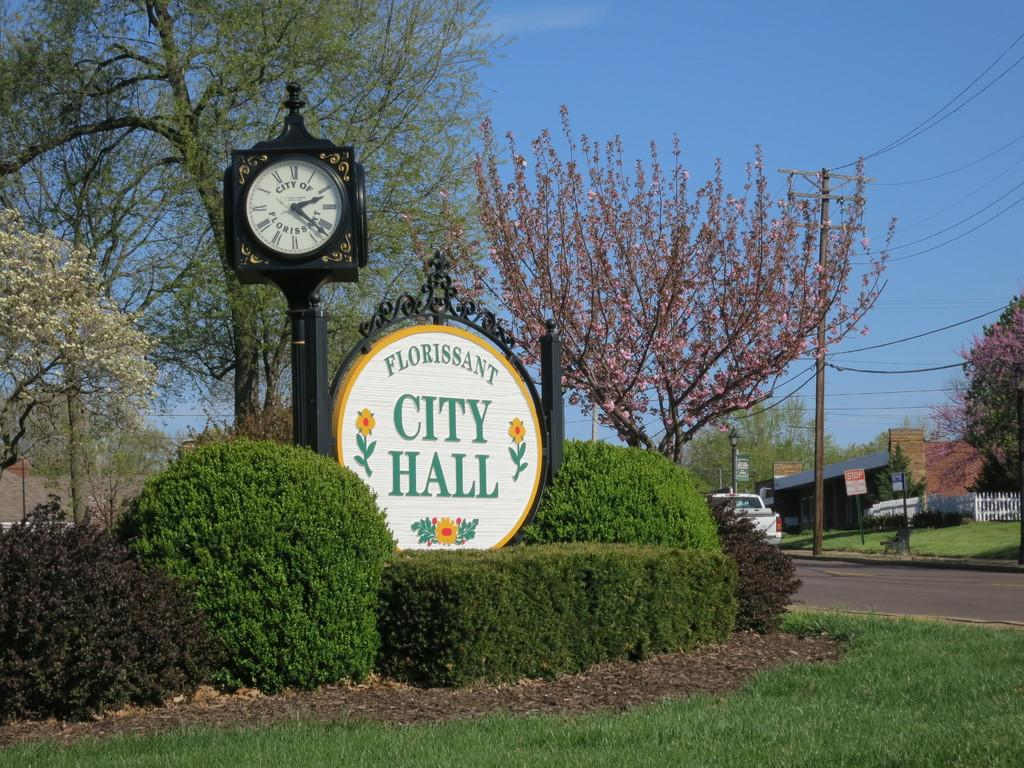Provide a one-sentence caption for the provided image. A picture of a sunny day featuring a sign for Floriessant City Hall. 